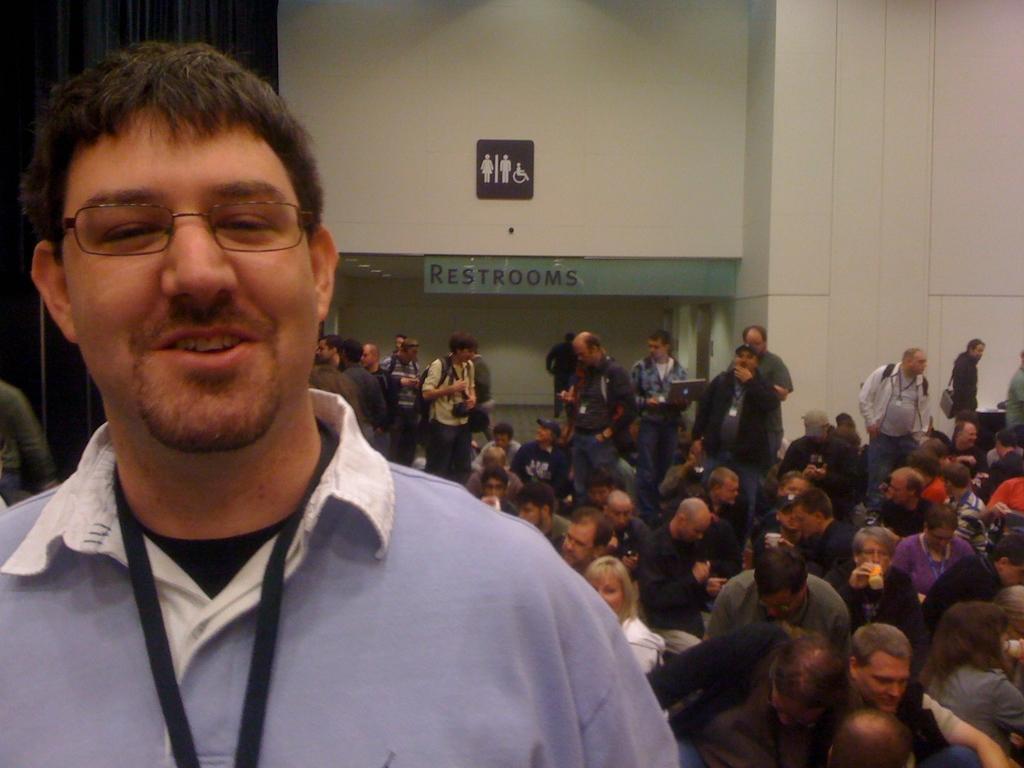Can you describe this image briefly? In the foreground of the picture there is a man smiling. In the center of the picture there are many people, few are holding cameras. At the background there is wall painted white. On the left there is a black curtain. 